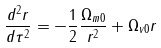<formula> <loc_0><loc_0><loc_500><loc_500>\frac { d ^ { 2 } r } { d \tau ^ { 2 } } = - \frac { 1 } { 2 } \frac { \Omega _ { m 0 } } { r ^ { 2 } } + \Omega _ { v 0 } r</formula> 